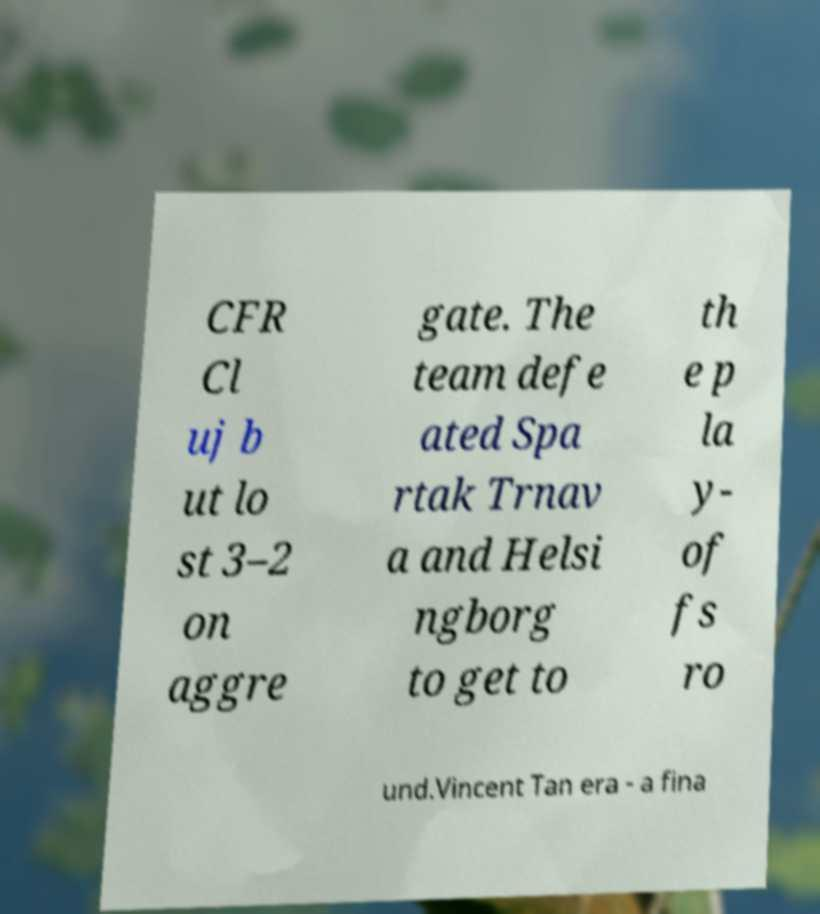There's text embedded in this image that I need extracted. Can you transcribe it verbatim? CFR Cl uj b ut lo st 3–2 on aggre gate. The team defe ated Spa rtak Trnav a and Helsi ngborg to get to th e p la y- of fs ro und.Vincent Tan era - a fina 